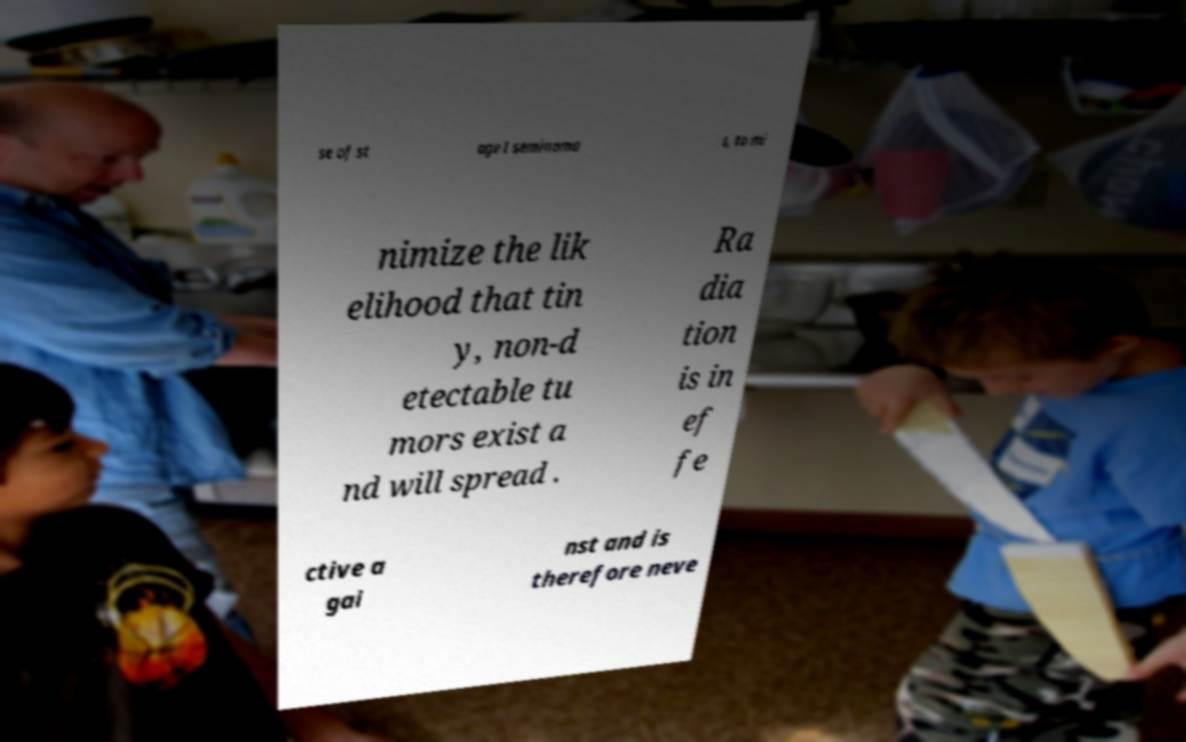Could you assist in decoding the text presented in this image and type it out clearly? se of st age I seminoma s, to mi nimize the lik elihood that tin y, non-d etectable tu mors exist a nd will spread . Ra dia tion is in ef fe ctive a gai nst and is therefore neve 